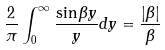<formula> <loc_0><loc_0><loc_500><loc_500>\frac { 2 } { \pi } \int _ { 0 } ^ { \infty } \frac { \sin \beta y } { y } d y = \frac { | \beta | } { \beta }</formula> 